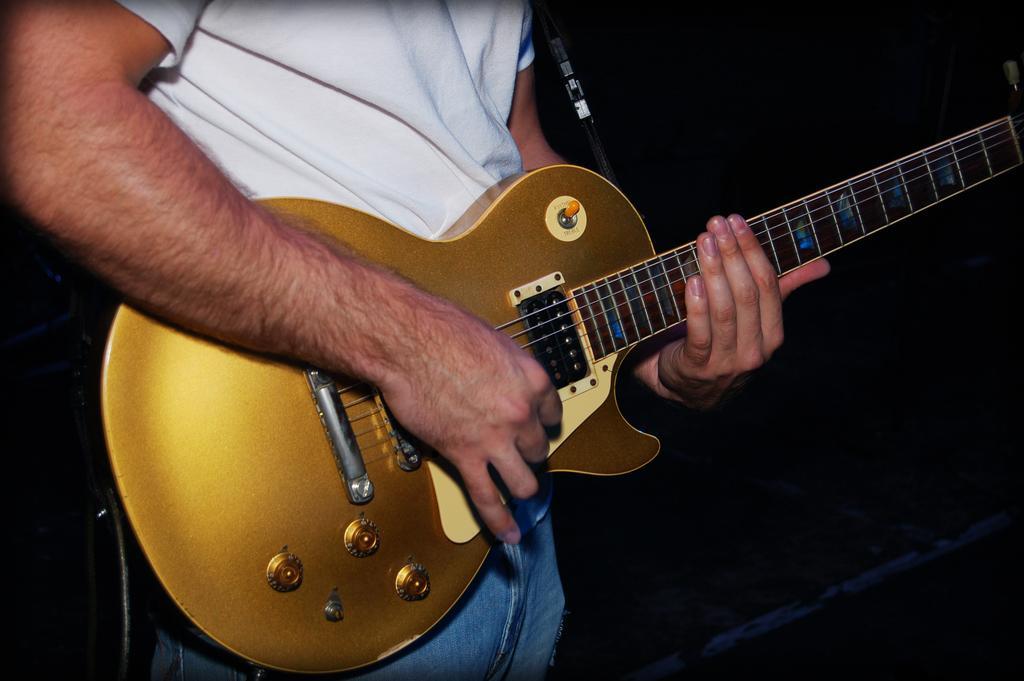Could you give a brief overview of what you see in this image? As we can see in the image there is a man wearing white color shirt and holding a guitar. 